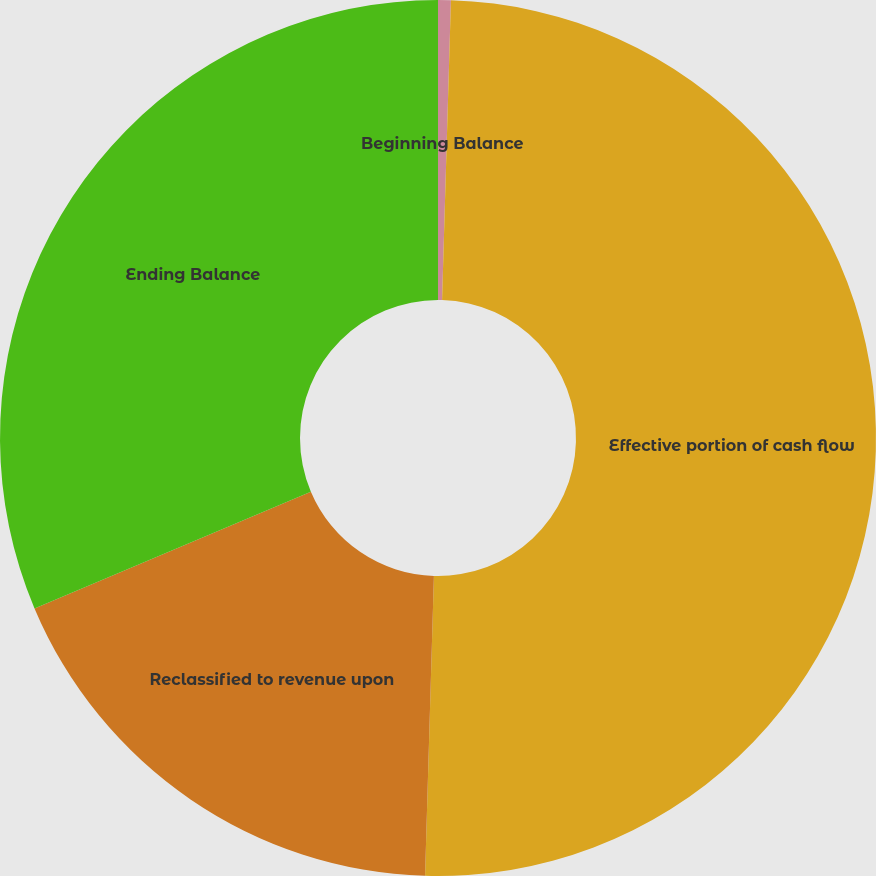Convert chart to OTSL. <chart><loc_0><loc_0><loc_500><loc_500><pie_chart><fcel>Beginning Balance<fcel>Effective portion of cash flow<fcel>Reclassified to revenue upon<fcel>Ending Balance<nl><fcel>0.47%<fcel>50.0%<fcel>18.17%<fcel>31.36%<nl></chart> 